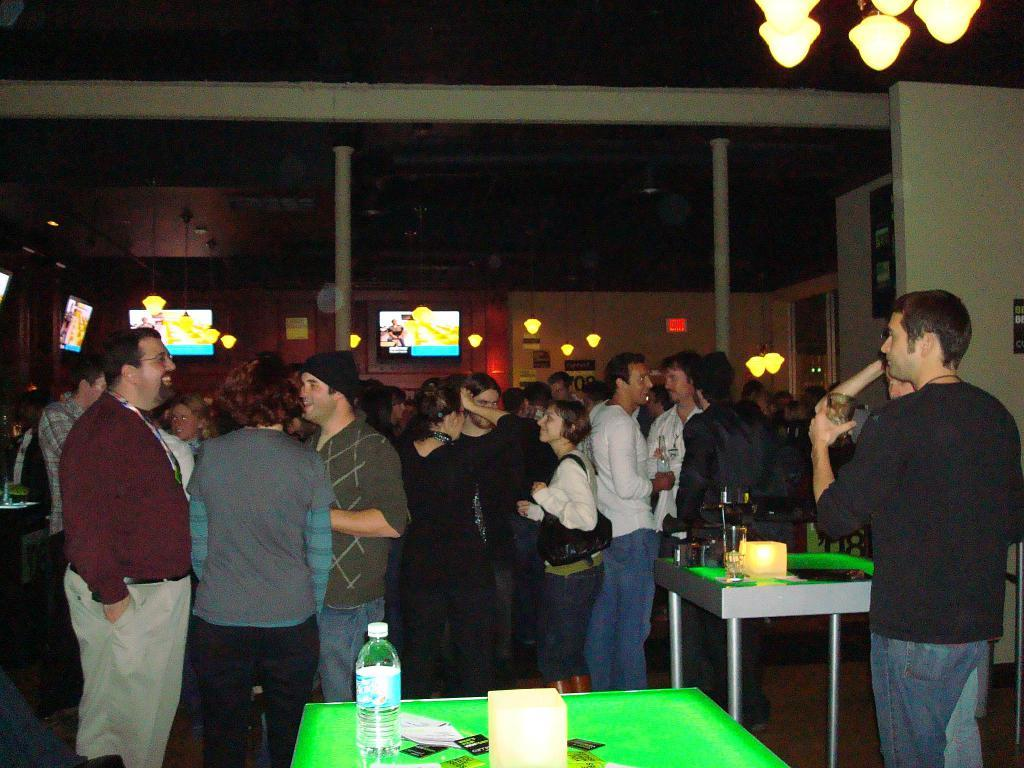What type of setting is depicted in the image? There is a room in the image. Who is present in the room? There are people in the room. What are the people doing in the room? The people are having a party. What furniture is present in the room? There are tables in the room. What can be found on the tables in the room? There are different items on the tables. What is the tendency of the fog to affect the party in the image? There is no fog present in the image, so it cannot affect the party. 